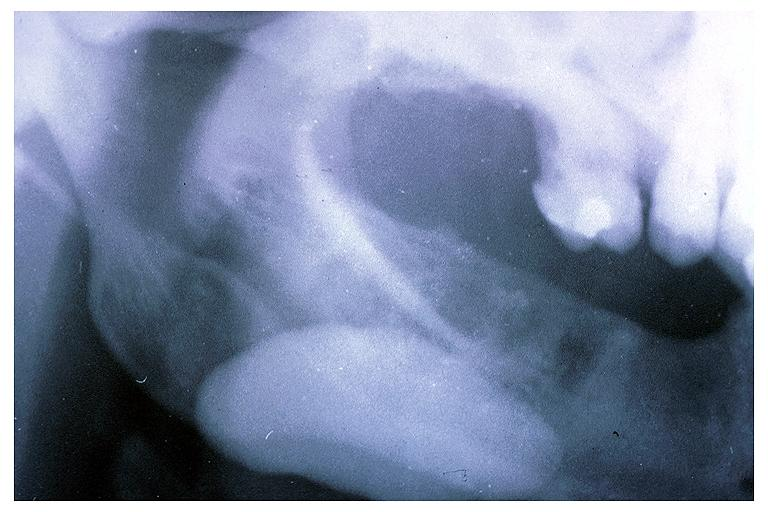where is this?
Answer the question using a single word or phrase. Oral 